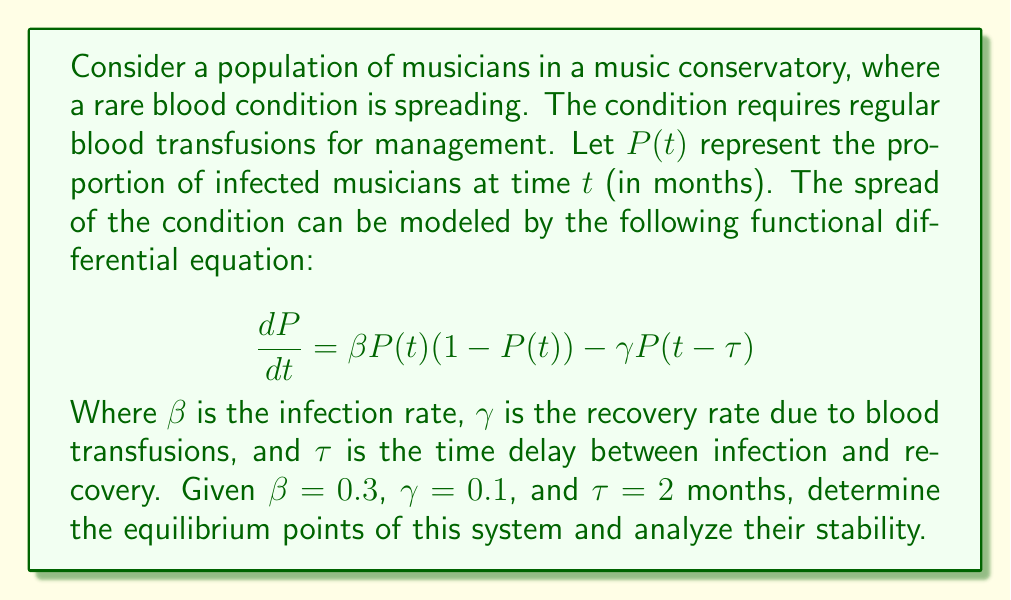Give your solution to this math problem. To solve this problem, we'll follow these steps:

1) Find the equilibrium points by setting $\frac{dP}{dt} = 0$:

   $$0 = \beta P(1-P) - \gamma P$$

2) Solve the resulting equation for $P$:

   $$0 = 0.3P(1-P) - 0.1P$$
   $$0 = 0.3P - 0.3P^2 - 0.1P$$
   $$0 = 0.2P - 0.3P^2$$
   $$P(0.2 - 0.3P) = 0$$

   This gives us two equilibrium points:
   $P_1 = 0$ and $P_2 = \frac{2}{3}$

3) To analyze stability, we need to linearize the system around each equilibrium point. Let $x(t) = P(t) - P^*$, where $P^*$ is the equilibrium point.

4) The linearized equation is:

   $$\frac{dx}{dt} = \beta(1-2P^*)x(t) - \gamma x(t-\tau)$$

5) For $P_1 = 0$:
   
   $$\frac{dx}{dt} = 0.3x(t) - 0.1x(t-2)$$

   The characteristic equation is:

   $$\lambda = 0.3 - 0.1e^{-2\lambda}$$

   This transcendental equation has roots with positive real parts, indicating that $P_1 = 0$ is unstable.

6) For $P_2 = \frac{2}{3}$:

   $$\frac{dx}{dt} = -0.1x(t) - 0.1x(t-2)$$

   The characteristic equation is:

   $$\lambda = -0.1 - 0.1e^{-2\lambda}$$

   All roots of this equation have negative real parts, indicating that $P_2 = \frac{2}{3}$ is stable.
Answer: The system has two equilibrium points: $P_1 = 0$ and $P_2 = \frac{2}{3}$. $P_1 = 0$ is unstable, while $P_2 = \frac{2}{3}$ is stable. 